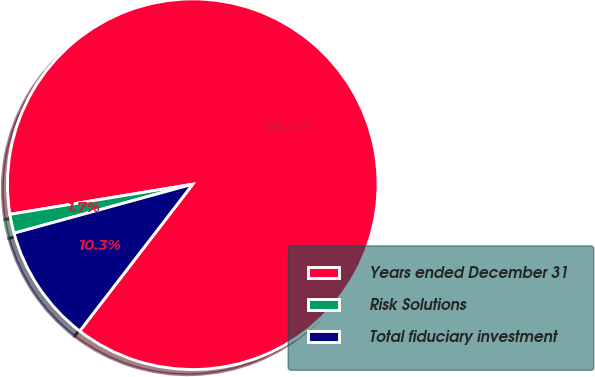Convert chart. <chart><loc_0><loc_0><loc_500><loc_500><pie_chart><fcel>Years ended December 31<fcel>Risk Solutions<fcel>Total fiduciary investment<nl><fcel>88.04%<fcel>1.66%<fcel>10.3%<nl></chart> 